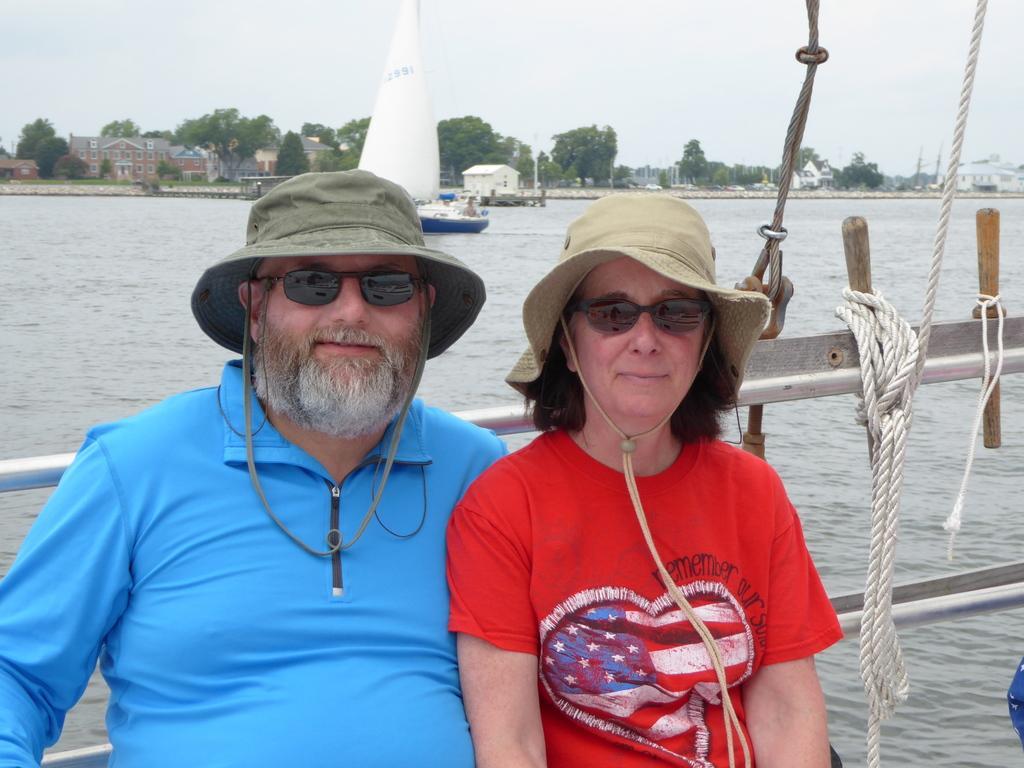Could you give a brief overview of what you see in this image? Here we can see a man and a woman and they have goggles. This is water and there is a boat. In the background we can see houses, trees, and sky. 